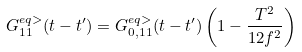Convert formula to latex. <formula><loc_0><loc_0><loc_500><loc_500>G _ { 1 1 } ^ { e q > } ( t - t ^ { \prime } ) = G _ { 0 , 1 1 } ^ { e q > } ( t - t ^ { \prime } ) \left ( 1 - \frac { T ^ { 2 } } { 1 2 f ^ { 2 } } \right )</formula> 